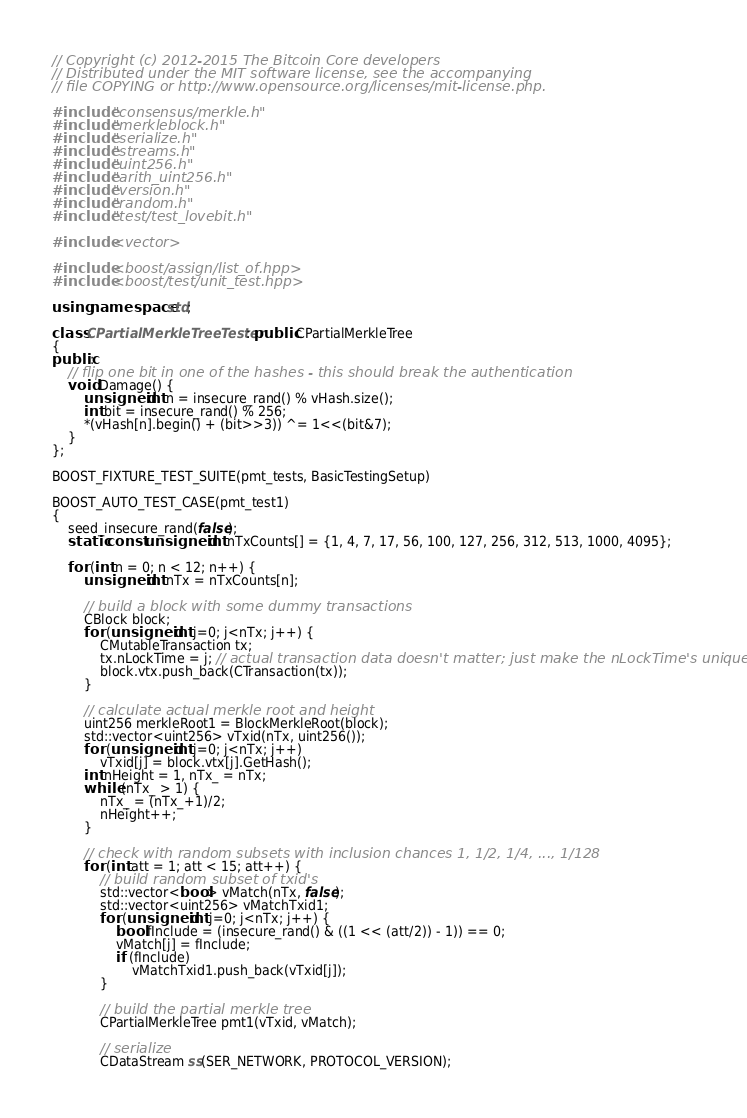<code> <loc_0><loc_0><loc_500><loc_500><_C++_>// Copyright (c) 2012-2015 The Bitcoin Core developers
// Distributed under the MIT software license, see the accompanying
// file COPYING or http://www.opensource.org/licenses/mit-license.php.

#include "consensus/merkle.h"
#include "merkleblock.h"
#include "serialize.h"
#include "streams.h"
#include "uint256.h"
#include "arith_uint256.h"
#include "version.h"
#include "random.h"
#include "test/test_lovebit.h"

#include <vector>

#include <boost/assign/list_of.hpp>
#include <boost/test/unit_test.hpp>

using namespace std;

class CPartialMerkleTreeTester : public CPartialMerkleTree
{
public:
    // flip one bit in one of the hashes - this should break the authentication
    void Damage() {
        unsigned int n = insecure_rand() % vHash.size();
        int bit = insecure_rand() % 256;
        *(vHash[n].begin() + (bit>>3)) ^= 1<<(bit&7);
    }
};

BOOST_FIXTURE_TEST_SUITE(pmt_tests, BasicTestingSetup)

BOOST_AUTO_TEST_CASE(pmt_test1)
{
    seed_insecure_rand(false);
    static const unsigned int nTxCounts[] = {1, 4, 7, 17, 56, 100, 127, 256, 312, 513, 1000, 4095};

    for (int n = 0; n < 12; n++) {
        unsigned int nTx = nTxCounts[n];

        // build a block with some dummy transactions
        CBlock block;
        for (unsigned int j=0; j<nTx; j++) {
            CMutableTransaction tx;
            tx.nLockTime = j; // actual transaction data doesn't matter; just make the nLockTime's unique
            block.vtx.push_back(CTransaction(tx));
        }

        // calculate actual merkle root and height
        uint256 merkleRoot1 = BlockMerkleRoot(block);
        std::vector<uint256> vTxid(nTx, uint256());
        for (unsigned int j=0; j<nTx; j++)
            vTxid[j] = block.vtx[j].GetHash();
        int nHeight = 1, nTx_ = nTx;
        while (nTx_ > 1) {
            nTx_ = (nTx_+1)/2;
            nHeight++;
        }

        // check with random subsets with inclusion chances 1, 1/2, 1/4, ..., 1/128
        for (int att = 1; att < 15; att++) {
            // build random subset of txid's
            std::vector<bool> vMatch(nTx, false);
            std::vector<uint256> vMatchTxid1;
            for (unsigned int j=0; j<nTx; j++) {
                bool fInclude = (insecure_rand() & ((1 << (att/2)) - 1)) == 0;
                vMatch[j] = fInclude;
                if (fInclude)
                    vMatchTxid1.push_back(vTxid[j]);
            }

            // build the partial merkle tree
            CPartialMerkleTree pmt1(vTxid, vMatch);

            // serialize
            CDataStream ss(SER_NETWORK, PROTOCOL_VERSION);</code> 